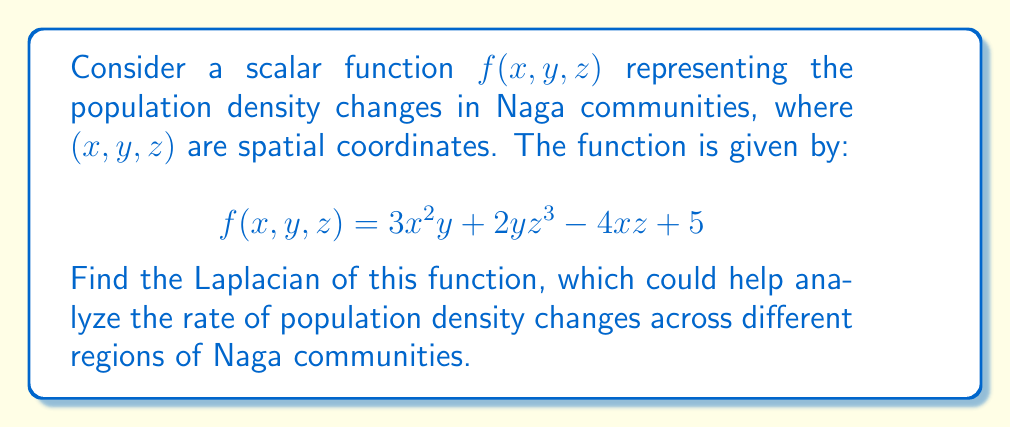Teach me how to tackle this problem. To find the Laplacian of the scalar function $f(x,y,z)$, we need to calculate the sum of its second partial derivatives with respect to each variable. The Laplacian is defined as:

$$\nabla^2f = \frac{\partial^2f}{\partial x^2} + \frac{\partial^2f}{\partial y^2} + \frac{\partial^2f}{\partial z^2}$$

Let's calculate each term:

1. $\frac{\partial^2f}{\partial x^2}$:
   First, $\frac{\partial f}{\partial x} = 6xy - 4z$
   Then, $\frac{\partial^2f}{\partial x^2} = 6y$

2. $\frac{\partial^2f}{\partial y^2}$:
   First, $\frac{\partial f}{\partial y} = 3x^2 + 2z^3$
   Then, $\frac{\partial^2f}{\partial y^2} = 0$

3. $\frac{\partial^2f}{\partial z^2}$:
   First, $\frac{\partial f}{\partial z} = 6yz^2 - 4x$
   Then, $\frac{\partial^2f}{\partial z^2} = 12yz$

Now, we sum these terms to get the Laplacian:

$$\nabla^2f = 6y + 0 + 12yz = 6y + 12yz = 6y(1 + 2z)$$

This result represents the rate of change of the population density gradient, which could be useful in analyzing population dynamics in different Naga communities.
Answer: $\nabla^2f = 6y(1 + 2z)$ 